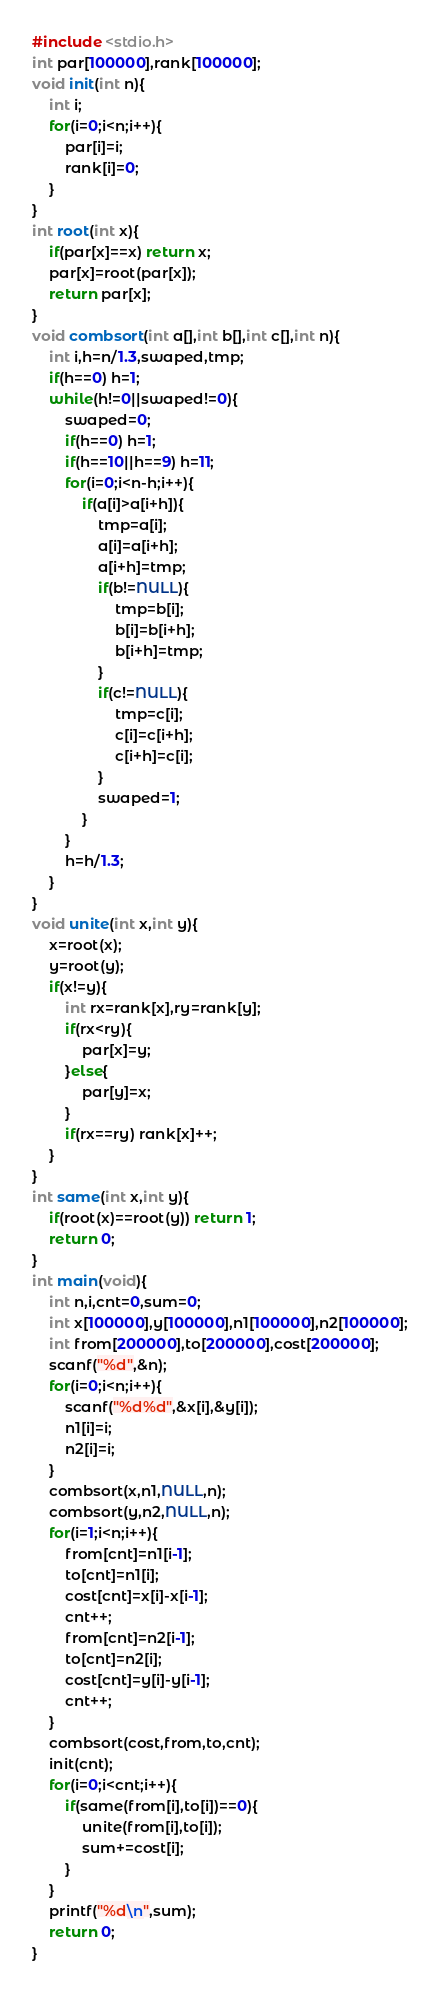<code> <loc_0><loc_0><loc_500><loc_500><_C_>#include <stdio.h>
int par[100000],rank[100000];
void init(int n){
    int i;
    for(i=0;i<n;i++){
        par[i]=i;
        rank[i]=0;
    }
}
int root(int x){
    if(par[x]==x) return x;
    par[x]=root(par[x]);
    return par[x];
}
void combsort(int a[],int b[],int c[],int n){
    int i,h=n/1.3,swaped,tmp;
    if(h==0) h=1;
    while(h!=0||swaped!=0){
        swaped=0;
        if(h==0) h=1;
        if(h==10||h==9) h=11;
        for(i=0;i<n-h;i++){
            if(a[i]>a[i+h]){
                tmp=a[i];
                a[i]=a[i+h];
                a[i+h]=tmp;
                if(b!=NULL){
                    tmp=b[i];
                    b[i]=b[i+h];
                    b[i+h]=tmp;
                }
                if(c!=NULL){
                    tmp=c[i];
                    c[i]=c[i+h];
                    c[i+h]=c[i];
                }
                swaped=1;
            }
        }
        h=h/1.3;
    }
}
void unite(int x,int y){
    x=root(x);
    y=root(y);
    if(x!=y){
        int rx=rank[x],ry=rank[y];
        if(rx<ry){
            par[x]=y;
        }else{
            par[y]=x;
        }
        if(rx==ry) rank[x]++;
    }
}
int same(int x,int y){
    if(root(x)==root(y)) return 1;
    return 0;
}
int main(void){
    int n,i,cnt=0,sum=0;
    int x[100000],y[100000],n1[100000],n2[100000];
    int from[200000],to[200000],cost[200000];
    scanf("%d",&n);
    for(i=0;i<n;i++){
        scanf("%d%d",&x[i],&y[i]);
        n1[i]=i;
        n2[i]=i;
    }
    combsort(x,n1,NULL,n);
    combsort(y,n2,NULL,n);
    for(i=1;i<n;i++){
        from[cnt]=n1[i-1];
        to[cnt]=n1[i];
        cost[cnt]=x[i]-x[i-1];
        cnt++;
        from[cnt]=n2[i-1];
        to[cnt]=n2[i];
        cost[cnt]=y[i]-y[i-1];
        cnt++;
    }
    combsort(cost,from,to,cnt);
    init(cnt);
    for(i=0;i<cnt;i++){
        if(same(from[i],to[i])==0){
            unite(from[i],to[i]);
            sum+=cost[i];
        }
    }
    printf("%d\n",sum);
    return 0;
}</code> 